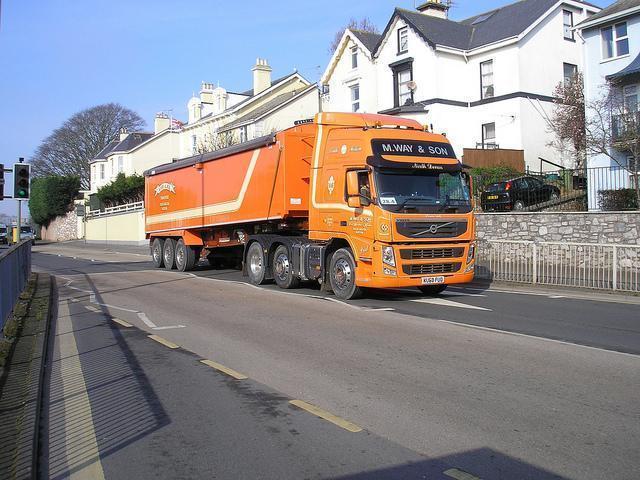What type of truck is this?
Pick the correct solution from the four options below to address the question.
Options: Model, ladder, commercial, passenger. Commercial. 